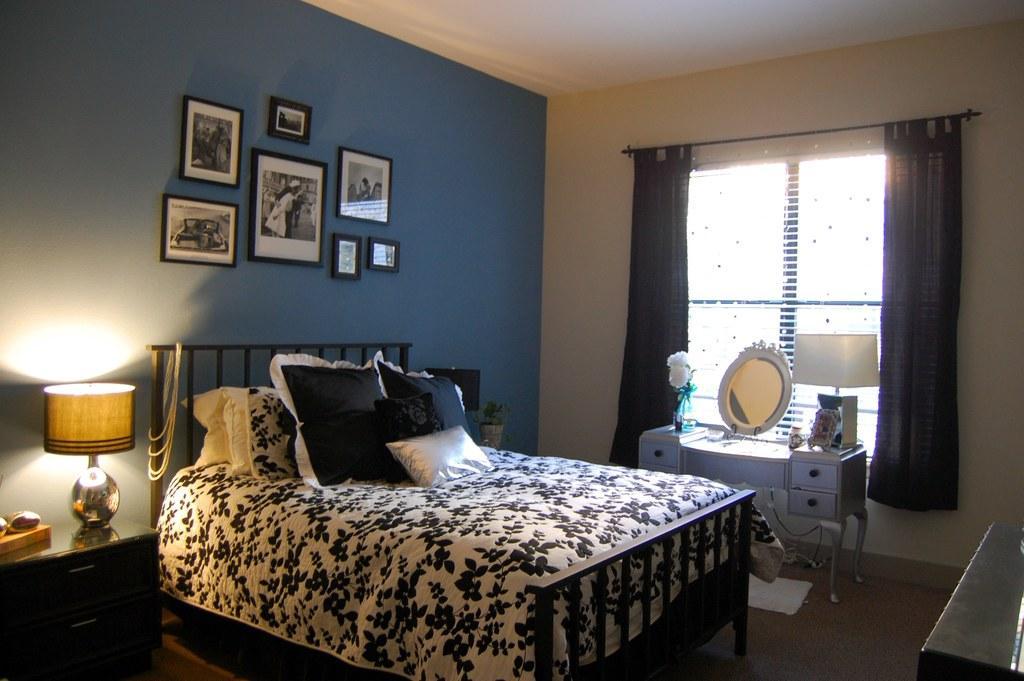Please provide a concise description of this image. This image consists of a room. There is window and curtains. There is cupboard like thing near the window and there is a mirror on that. There is lamb too. There is a bed in the middle of the room, there are pillows on that. There is a lamp on the left side. There are photo frames on the wall. 